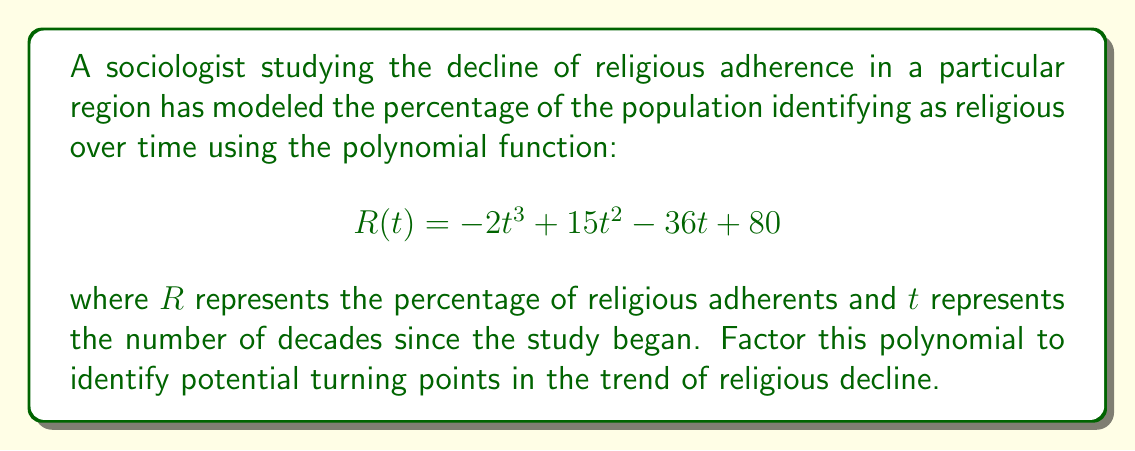What is the answer to this math problem? To factor this polynomial, we'll follow these steps:

1) First, let's check if there's a common factor:
   There isn't, so we move on.

2) This is a cubic function, so we'll try to factor it as:
   $$(at + b)(t^2 + ct + d)$$

3) We can find one factor by guessing roots. The possible rational roots are the factors of the constant term (80): ±1, ±2, ±4, ±5, ±8, ±10, ±16, ±20, ±40, ±80.

4) Testing these, we find that $t = 4$ is a root. So $(t - 4)$ is a factor.

5) We can now use polynomial long division to find the other factor:

   $$
   \begin{array}{r}
   t^2 + 7t - 20 \\
   t - 4 \enclose{longdiv}{t^3 - 15t^2 + 36t - 80} \\
   \underline{t^3 - 4t^2} \\
   -11t^2 + 36t \\
   \underline{-11t^2 + 44t} \\
   -8t - 80 \\
   \underline{-8t + 32} \\
   -112
   \end{array}
   $$

6) So, $R(t) = -2(t - 4)(t^2 + 7t - 20)$

7) We can further factor the quadratic term:
   $t^2 + 7t - 20 = (t + 10)(t - 3)$

Therefore, the fully factored polynomial is:

$$R(t) = -2(t - 4)(t + 10)(t - 3)$$

This factorization reveals that the function has roots at $t = 4$, $t = 3$, and $t = -10$. The root at $t = -10$ is not relevant to our context as time cannot be negative in this model. The roots at $t = 3$ and $t = 4$ represent decades where religious adherence reaches 0%, potentially indicating complete secularization.
Answer: $$R(t) = -2(t - 4)(t + 10)(t - 3)$$ 